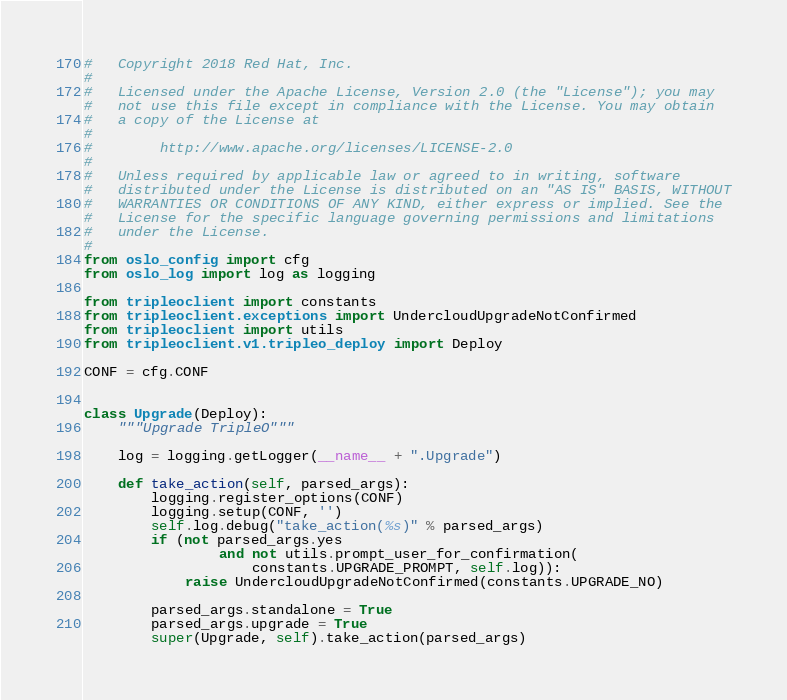Convert code to text. <code><loc_0><loc_0><loc_500><loc_500><_Python_>#   Copyright 2018 Red Hat, Inc.
#
#   Licensed under the Apache License, Version 2.0 (the "License"); you may
#   not use this file except in compliance with the License. You may obtain
#   a copy of the License at
#
#        http://www.apache.org/licenses/LICENSE-2.0
#
#   Unless required by applicable law or agreed to in writing, software
#   distributed under the License is distributed on an "AS IS" BASIS, WITHOUT
#   WARRANTIES OR CONDITIONS OF ANY KIND, either express or implied. See the
#   License for the specific language governing permissions and limitations
#   under the License.
#
from oslo_config import cfg
from oslo_log import log as logging

from tripleoclient import constants
from tripleoclient.exceptions import UndercloudUpgradeNotConfirmed
from tripleoclient import utils
from tripleoclient.v1.tripleo_deploy import Deploy

CONF = cfg.CONF


class Upgrade(Deploy):
    """Upgrade TripleO"""

    log = logging.getLogger(__name__ + ".Upgrade")

    def take_action(self, parsed_args):
        logging.register_options(CONF)
        logging.setup(CONF, '')
        self.log.debug("take_action(%s)" % parsed_args)
        if (not parsed_args.yes
                and not utils.prompt_user_for_confirmation(
                    constants.UPGRADE_PROMPT, self.log)):
            raise UndercloudUpgradeNotConfirmed(constants.UPGRADE_NO)

        parsed_args.standalone = True
        parsed_args.upgrade = True
        super(Upgrade, self).take_action(parsed_args)
</code> 